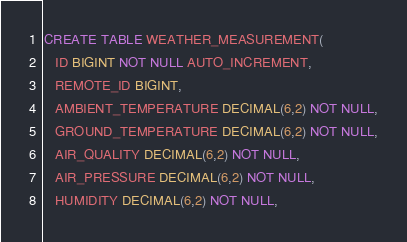<code> <loc_0><loc_0><loc_500><loc_500><_SQL_>CREATE TABLE WEATHER_MEASUREMENT(
   ID BIGINT NOT NULL AUTO_INCREMENT,
   REMOTE_ID BIGINT,
   AMBIENT_TEMPERATURE DECIMAL(6,2) NOT NULL,
   GROUND_TEMPERATURE DECIMAL(6,2) NOT NULL,
   AIR_QUALITY DECIMAL(6,2) NOT NULL,
   AIR_PRESSURE DECIMAL(6,2) NOT NULL,
   HUMIDITY DECIMAL(6,2) NOT NULL,</code> 